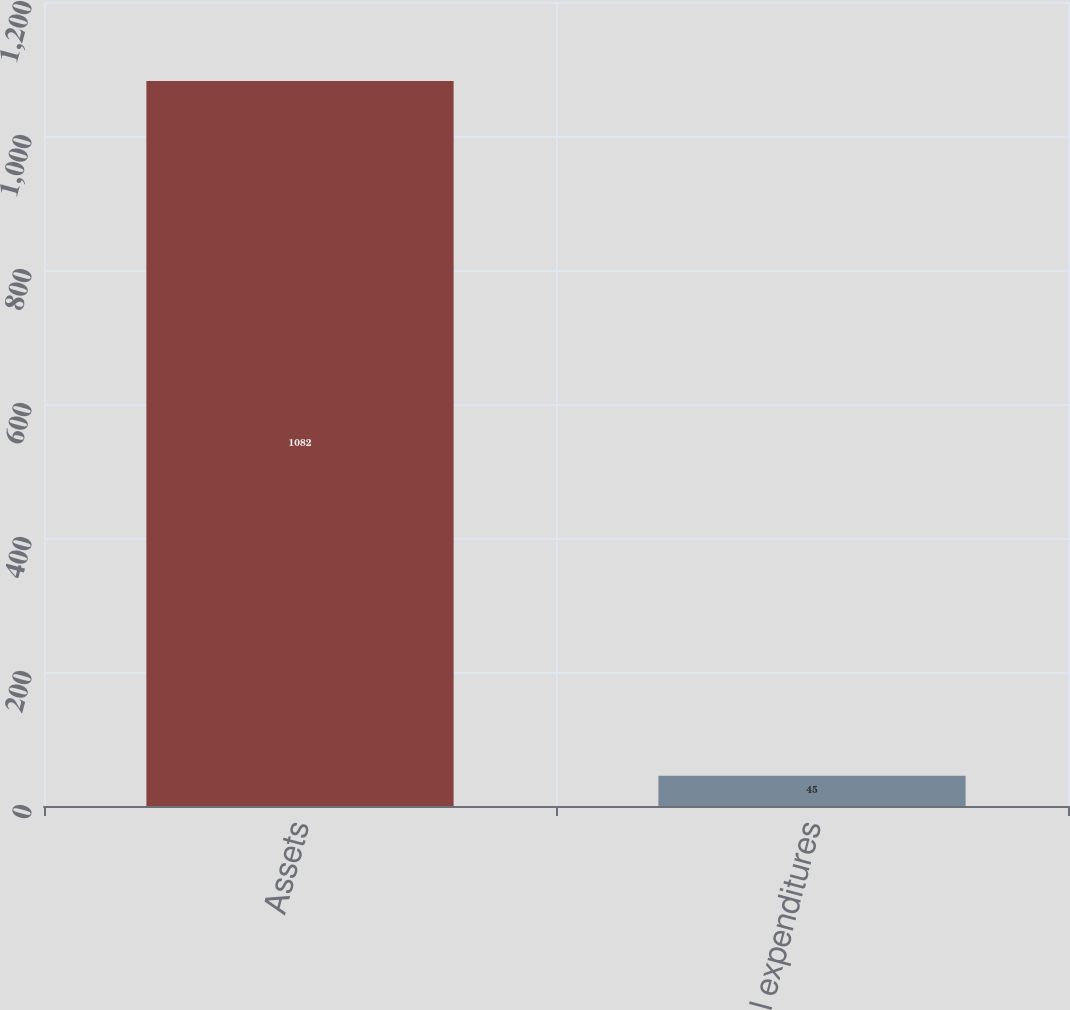Convert chart to OTSL. <chart><loc_0><loc_0><loc_500><loc_500><bar_chart><fcel>Assets<fcel>Capital expenditures<nl><fcel>1082<fcel>45<nl></chart> 